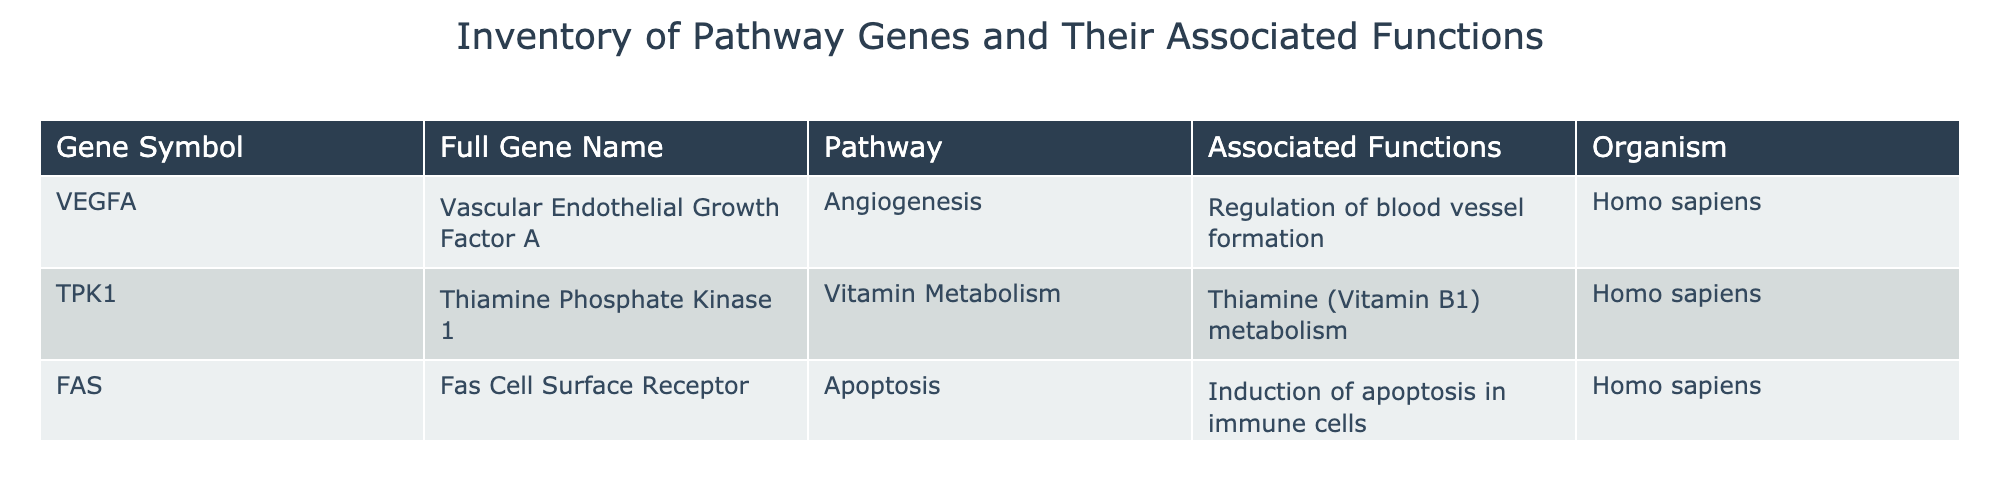What is the full gene name for VEGFA? The table lists the full gene name for VEGFA in the second column. By locating the row that contains VEGFA, I can see that its full gene name is "Vascular Endothelial Growth Factor A."
Answer: Vascular Endothelial Growth Factor A Which gene is associated with apoptosis? To determine which gene is associated with apoptosis, I can refer to the "Pathway" column and look for the entry that mentions "Apoptosis." The row for the gene symbol FAS indicates that it is associated with apoptosis.
Answer: FAS How many genes are involved in Vitamin Metabolism? In the table, I need to count the number of entries in the "Pathway" column that are listed as "Vitamin Metabolism." There is only one gene, TPK1, in that pathway, which means there is one gene involved.
Answer: 1 Does VEGFA have a function related to immune cells? I need to look for the associated functions for VEGFA. The function listed is "Regulation of blood vessel formation," which does not relate to immune cells as the function of FAS does. Therefore, the answer is no.
Answer: No Which functional category has the highest representation in the table? To answer this, I can tally the unique functions associated with each gene. The functions are "Regulation of blood vessel formation," "Thiamine (Vitamin B1) metabolism," and "Induction of apoptosis in immune cells." Each function represents one gene only; hence, there is no highest representation. The answer reflects that there is an equal distribution among them.
Answer: None 